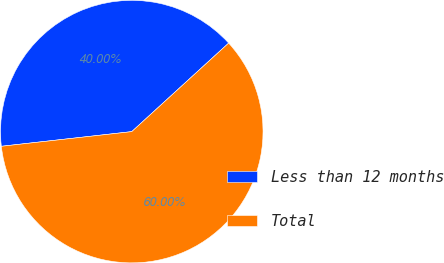<chart> <loc_0><loc_0><loc_500><loc_500><pie_chart><fcel>Less than 12 months<fcel>Total<nl><fcel>40.0%<fcel>60.0%<nl></chart> 